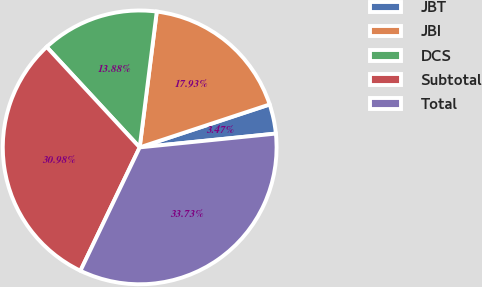Convert chart to OTSL. <chart><loc_0><loc_0><loc_500><loc_500><pie_chart><fcel>JBT<fcel>JBI<fcel>DCS<fcel>Subtotal<fcel>Total<nl><fcel>3.47%<fcel>17.93%<fcel>13.88%<fcel>30.98%<fcel>33.73%<nl></chart> 